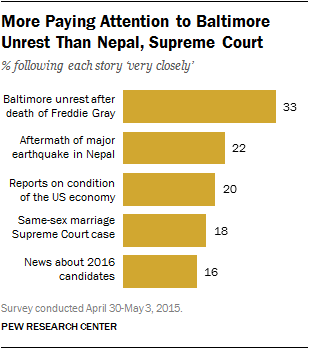Point out several critical features in this image. The values of the highest and lowest yellow bars in a bar chart are different by 17. The maximum value of the yellow bar is 33. 